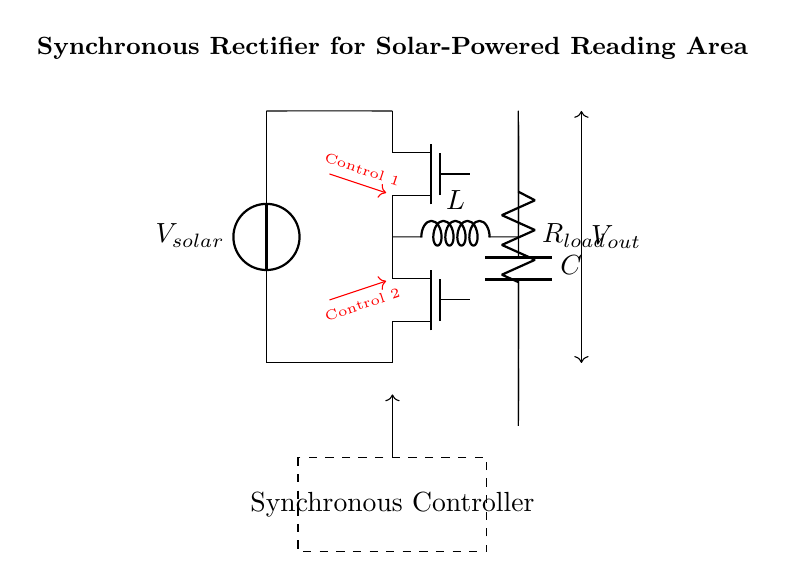What does the control signal "Control 1" indicate? This signal controls the operation of the first MOSFET switch (S1) in the synchronous rectifier circuit. The name "Control 1" suggests it is the first control signal that directs the timing or state of this component.
Answer: First MOSFET What is the role of the inductor in this circuit? The inductor (L) stores energy and helps to smooth the output voltage by controlling the current flow in relation to the load and the switches. It plays a crucial role in energy transfer from the solar panel to the load, allowing for efficient power conversion.
Answer: Energy storage How many MOSFET switches are used? There are two MOSFET switches (S1 and S2) in this circuit, which work together for synchronous rectification. They replace traditional diodes to enhance efficiency by reducing voltage drop and power losses.
Answer: Two What is the purpose of the capacitor in this circuit? The capacitor (C) filters and stabilizes the output voltage by smoothing out the fluctuations caused by the switching actions of the MOSFETs, ensuring a steady supply of power to the load.
Answer: Smoothing output What are the components connected to the solar panel? The components connected to the solar panel include two MOSFET switches (S1, S2), an inductor (L), a capacitor (C), and a load resistor (R_load). These components together form the synchronous rectifier circuit that improves power efficiency for the outdoor reading area installation.
Answer: MOSFETs, Inductor, Capacitor, Load How does this circuit improve efficiency compared to traditional rectifiers? This synchronous rectifier circuit replaces standard diodes with MOSFETs, which have lower forward voltage drop, hence reducing power losses. The control signals enable precise switching and minimize energy waste during operation, significantly improving power conversion efficiency particularly in solar applications.
Answer: Lower power losses 